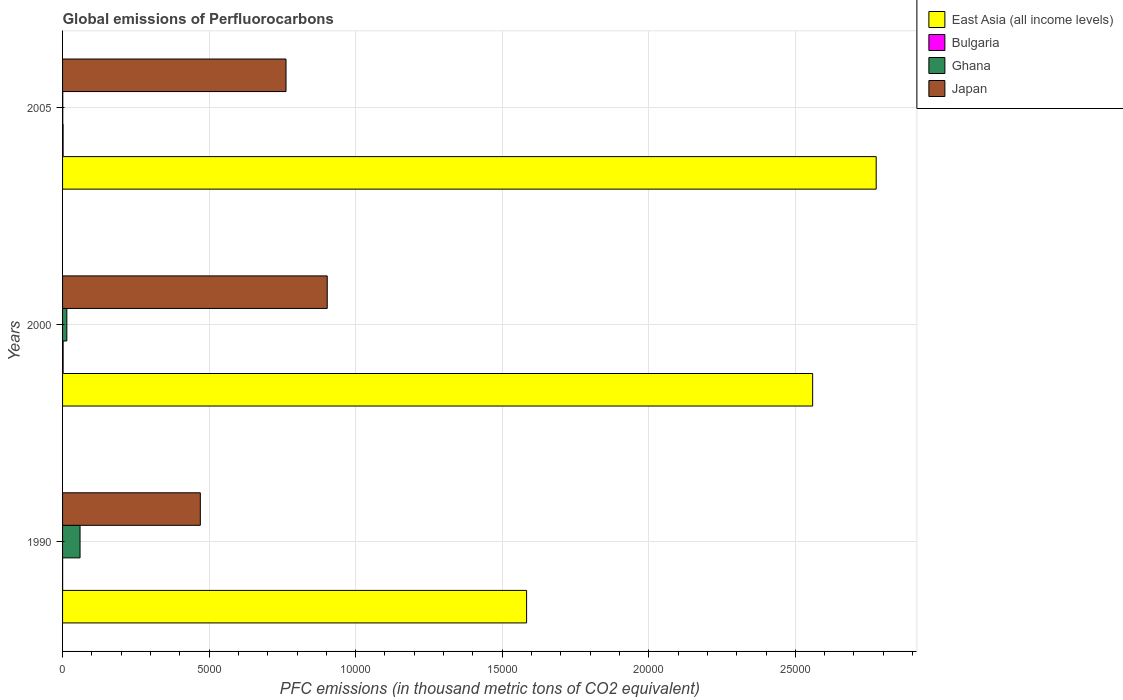How many different coloured bars are there?
Provide a short and direct response. 4. Are the number of bars on each tick of the Y-axis equal?
Make the answer very short. Yes. How many bars are there on the 1st tick from the top?
Offer a very short reply. 4. How many bars are there on the 1st tick from the bottom?
Provide a succinct answer. 4. In how many cases, is the number of bars for a given year not equal to the number of legend labels?
Make the answer very short. 0. What is the global emissions of Perfluorocarbons in Ghana in 2005?
Offer a terse response. 6.9. Across all years, what is the maximum global emissions of Perfluorocarbons in Bulgaria?
Your response must be concise. 19.1. Across all years, what is the minimum global emissions of Perfluorocarbons in Ghana?
Your response must be concise. 6.9. What is the total global emissions of Perfluorocarbons in Ghana in the graph?
Offer a very short reply. 749.2. What is the difference between the global emissions of Perfluorocarbons in Bulgaria in 2000 and that in 2005?
Your answer should be compact. 0.6. What is the difference between the global emissions of Perfluorocarbons in Bulgaria in 2005 and the global emissions of Perfluorocarbons in Japan in 2000?
Give a very brief answer. -9011.3. What is the average global emissions of Perfluorocarbons in East Asia (all income levels) per year?
Your response must be concise. 2.31e+04. In the year 2000, what is the difference between the global emissions of Perfluorocarbons in East Asia (all income levels) and global emissions of Perfluorocarbons in Bulgaria?
Make the answer very short. 2.56e+04. In how many years, is the global emissions of Perfluorocarbons in East Asia (all income levels) greater than 10000 thousand metric tons?
Offer a very short reply. 3. What is the ratio of the global emissions of Perfluorocarbons in Ghana in 2000 to that in 2005?
Ensure brevity in your answer.  21.17. What is the difference between the highest and the second highest global emissions of Perfluorocarbons in Bulgaria?
Keep it short and to the point. 0.6. What is the difference between the highest and the lowest global emissions of Perfluorocarbons in Japan?
Ensure brevity in your answer.  4329.8. Is the sum of the global emissions of Perfluorocarbons in Bulgaria in 2000 and 2005 greater than the maximum global emissions of Perfluorocarbons in Japan across all years?
Offer a very short reply. No. Is it the case that in every year, the sum of the global emissions of Perfluorocarbons in Japan and global emissions of Perfluorocarbons in East Asia (all income levels) is greater than the sum of global emissions of Perfluorocarbons in Ghana and global emissions of Perfluorocarbons in Bulgaria?
Ensure brevity in your answer.  Yes. What does the 4th bar from the top in 1990 represents?
Offer a terse response. East Asia (all income levels). Is it the case that in every year, the sum of the global emissions of Perfluorocarbons in Japan and global emissions of Perfluorocarbons in East Asia (all income levels) is greater than the global emissions of Perfluorocarbons in Bulgaria?
Your response must be concise. Yes. How many bars are there?
Ensure brevity in your answer.  12. Are all the bars in the graph horizontal?
Make the answer very short. Yes. Where does the legend appear in the graph?
Give a very brief answer. Top right. How many legend labels are there?
Ensure brevity in your answer.  4. How are the legend labels stacked?
Make the answer very short. Vertical. What is the title of the graph?
Provide a succinct answer. Global emissions of Perfluorocarbons. Does "Peru" appear as one of the legend labels in the graph?
Your answer should be very brief. No. What is the label or title of the X-axis?
Your answer should be compact. PFC emissions (in thousand metric tons of CO2 equivalent). What is the PFC emissions (in thousand metric tons of CO2 equivalent) of East Asia (all income levels) in 1990?
Make the answer very short. 1.58e+04. What is the PFC emissions (in thousand metric tons of CO2 equivalent) in Ghana in 1990?
Ensure brevity in your answer.  596.2. What is the PFC emissions (in thousand metric tons of CO2 equivalent) of Japan in 1990?
Your response must be concise. 4700. What is the PFC emissions (in thousand metric tons of CO2 equivalent) in East Asia (all income levels) in 2000?
Your answer should be compact. 2.56e+04. What is the PFC emissions (in thousand metric tons of CO2 equivalent) of Bulgaria in 2000?
Keep it short and to the point. 19.1. What is the PFC emissions (in thousand metric tons of CO2 equivalent) in Ghana in 2000?
Provide a short and direct response. 146.1. What is the PFC emissions (in thousand metric tons of CO2 equivalent) in Japan in 2000?
Ensure brevity in your answer.  9029.8. What is the PFC emissions (in thousand metric tons of CO2 equivalent) in East Asia (all income levels) in 2005?
Keep it short and to the point. 2.78e+04. What is the PFC emissions (in thousand metric tons of CO2 equivalent) of Bulgaria in 2005?
Your answer should be very brief. 18.5. What is the PFC emissions (in thousand metric tons of CO2 equivalent) in Japan in 2005?
Your response must be concise. 7623.6. Across all years, what is the maximum PFC emissions (in thousand metric tons of CO2 equivalent) of East Asia (all income levels)?
Ensure brevity in your answer.  2.78e+04. Across all years, what is the maximum PFC emissions (in thousand metric tons of CO2 equivalent) of Ghana?
Provide a succinct answer. 596.2. Across all years, what is the maximum PFC emissions (in thousand metric tons of CO2 equivalent) in Japan?
Provide a succinct answer. 9029.8. Across all years, what is the minimum PFC emissions (in thousand metric tons of CO2 equivalent) of East Asia (all income levels)?
Provide a succinct answer. 1.58e+04. Across all years, what is the minimum PFC emissions (in thousand metric tons of CO2 equivalent) in Japan?
Ensure brevity in your answer.  4700. What is the total PFC emissions (in thousand metric tons of CO2 equivalent) of East Asia (all income levels) in the graph?
Keep it short and to the point. 6.92e+04. What is the total PFC emissions (in thousand metric tons of CO2 equivalent) of Bulgaria in the graph?
Your answer should be very brief. 39.8. What is the total PFC emissions (in thousand metric tons of CO2 equivalent) of Ghana in the graph?
Ensure brevity in your answer.  749.2. What is the total PFC emissions (in thousand metric tons of CO2 equivalent) in Japan in the graph?
Ensure brevity in your answer.  2.14e+04. What is the difference between the PFC emissions (in thousand metric tons of CO2 equivalent) of East Asia (all income levels) in 1990 and that in 2000?
Your answer should be very brief. -9759.3. What is the difference between the PFC emissions (in thousand metric tons of CO2 equivalent) in Bulgaria in 1990 and that in 2000?
Provide a short and direct response. -16.9. What is the difference between the PFC emissions (in thousand metric tons of CO2 equivalent) of Ghana in 1990 and that in 2000?
Make the answer very short. 450.1. What is the difference between the PFC emissions (in thousand metric tons of CO2 equivalent) in Japan in 1990 and that in 2000?
Keep it short and to the point. -4329.8. What is the difference between the PFC emissions (in thousand metric tons of CO2 equivalent) of East Asia (all income levels) in 1990 and that in 2005?
Provide a succinct answer. -1.19e+04. What is the difference between the PFC emissions (in thousand metric tons of CO2 equivalent) in Bulgaria in 1990 and that in 2005?
Offer a very short reply. -16.3. What is the difference between the PFC emissions (in thousand metric tons of CO2 equivalent) in Ghana in 1990 and that in 2005?
Offer a very short reply. 589.3. What is the difference between the PFC emissions (in thousand metric tons of CO2 equivalent) of Japan in 1990 and that in 2005?
Provide a succinct answer. -2923.6. What is the difference between the PFC emissions (in thousand metric tons of CO2 equivalent) in East Asia (all income levels) in 2000 and that in 2005?
Your response must be concise. -2167.69. What is the difference between the PFC emissions (in thousand metric tons of CO2 equivalent) of Bulgaria in 2000 and that in 2005?
Ensure brevity in your answer.  0.6. What is the difference between the PFC emissions (in thousand metric tons of CO2 equivalent) of Ghana in 2000 and that in 2005?
Your answer should be compact. 139.2. What is the difference between the PFC emissions (in thousand metric tons of CO2 equivalent) in Japan in 2000 and that in 2005?
Your answer should be very brief. 1406.2. What is the difference between the PFC emissions (in thousand metric tons of CO2 equivalent) of East Asia (all income levels) in 1990 and the PFC emissions (in thousand metric tons of CO2 equivalent) of Bulgaria in 2000?
Provide a succinct answer. 1.58e+04. What is the difference between the PFC emissions (in thousand metric tons of CO2 equivalent) in East Asia (all income levels) in 1990 and the PFC emissions (in thousand metric tons of CO2 equivalent) in Ghana in 2000?
Ensure brevity in your answer.  1.57e+04. What is the difference between the PFC emissions (in thousand metric tons of CO2 equivalent) in East Asia (all income levels) in 1990 and the PFC emissions (in thousand metric tons of CO2 equivalent) in Japan in 2000?
Provide a succinct answer. 6801.9. What is the difference between the PFC emissions (in thousand metric tons of CO2 equivalent) of Bulgaria in 1990 and the PFC emissions (in thousand metric tons of CO2 equivalent) of Ghana in 2000?
Your answer should be compact. -143.9. What is the difference between the PFC emissions (in thousand metric tons of CO2 equivalent) of Bulgaria in 1990 and the PFC emissions (in thousand metric tons of CO2 equivalent) of Japan in 2000?
Give a very brief answer. -9027.6. What is the difference between the PFC emissions (in thousand metric tons of CO2 equivalent) in Ghana in 1990 and the PFC emissions (in thousand metric tons of CO2 equivalent) in Japan in 2000?
Your response must be concise. -8433.6. What is the difference between the PFC emissions (in thousand metric tons of CO2 equivalent) in East Asia (all income levels) in 1990 and the PFC emissions (in thousand metric tons of CO2 equivalent) in Bulgaria in 2005?
Keep it short and to the point. 1.58e+04. What is the difference between the PFC emissions (in thousand metric tons of CO2 equivalent) in East Asia (all income levels) in 1990 and the PFC emissions (in thousand metric tons of CO2 equivalent) in Ghana in 2005?
Provide a short and direct response. 1.58e+04. What is the difference between the PFC emissions (in thousand metric tons of CO2 equivalent) of East Asia (all income levels) in 1990 and the PFC emissions (in thousand metric tons of CO2 equivalent) of Japan in 2005?
Make the answer very short. 8208.1. What is the difference between the PFC emissions (in thousand metric tons of CO2 equivalent) of Bulgaria in 1990 and the PFC emissions (in thousand metric tons of CO2 equivalent) of Ghana in 2005?
Provide a succinct answer. -4.7. What is the difference between the PFC emissions (in thousand metric tons of CO2 equivalent) of Bulgaria in 1990 and the PFC emissions (in thousand metric tons of CO2 equivalent) of Japan in 2005?
Your answer should be very brief. -7621.4. What is the difference between the PFC emissions (in thousand metric tons of CO2 equivalent) in Ghana in 1990 and the PFC emissions (in thousand metric tons of CO2 equivalent) in Japan in 2005?
Your answer should be very brief. -7027.4. What is the difference between the PFC emissions (in thousand metric tons of CO2 equivalent) in East Asia (all income levels) in 2000 and the PFC emissions (in thousand metric tons of CO2 equivalent) in Bulgaria in 2005?
Your answer should be compact. 2.56e+04. What is the difference between the PFC emissions (in thousand metric tons of CO2 equivalent) of East Asia (all income levels) in 2000 and the PFC emissions (in thousand metric tons of CO2 equivalent) of Ghana in 2005?
Give a very brief answer. 2.56e+04. What is the difference between the PFC emissions (in thousand metric tons of CO2 equivalent) in East Asia (all income levels) in 2000 and the PFC emissions (in thousand metric tons of CO2 equivalent) in Japan in 2005?
Provide a succinct answer. 1.80e+04. What is the difference between the PFC emissions (in thousand metric tons of CO2 equivalent) in Bulgaria in 2000 and the PFC emissions (in thousand metric tons of CO2 equivalent) in Ghana in 2005?
Provide a short and direct response. 12.2. What is the difference between the PFC emissions (in thousand metric tons of CO2 equivalent) of Bulgaria in 2000 and the PFC emissions (in thousand metric tons of CO2 equivalent) of Japan in 2005?
Make the answer very short. -7604.5. What is the difference between the PFC emissions (in thousand metric tons of CO2 equivalent) of Ghana in 2000 and the PFC emissions (in thousand metric tons of CO2 equivalent) of Japan in 2005?
Keep it short and to the point. -7477.5. What is the average PFC emissions (in thousand metric tons of CO2 equivalent) in East Asia (all income levels) per year?
Your answer should be compact. 2.31e+04. What is the average PFC emissions (in thousand metric tons of CO2 equivalent) in Bulgaria per year?
Make the answer very short. 13.27. What is the average PFC emissions (in thousand metric tons of CO2 equivalent) of Ghana per year?
Ensure brevity in your answer.  249.73. What is the average PFC emissions (in thousand metric tons of CO2 equivalent) in Japan per year?
Provide a short and direct response. 7117.8. In the year 1990, what is the difference between the PFC emissions (in thousand metric tons of CO2 equivalent) of East Asia (all income levels) and PFC emissions (in thousand metric tons of CO2 equivalent) of Bulgaria?
Your response must be concise. 1.58e+04. In the year 1990, what is the difference between the PFC emissions (in thousand metric tons of CO2 equivalent) of East Asia (all income levels) and PFC emissions (in thousand metric tons of CO2 equivalent) of Ghana?
Ensure brevity in your answer.  1.52e+04. In the year 1990, what is the difference between the PFC emissions (in thousand metric tons of CO2 equivalent) in East Asia (all income levels) and PFC emissions (in thousand metric tons of CO2 equivalent) in Japan?
Provide a short and direct response. 1.11e+04. In the year 1990, what is the difference between the PFC emissions (in thousand metric tons of CO2 equivalent) in Bulgaria and PFC emissions (in thousand metric tons of CO2 equivalent) in Ghana?
Provide a short and direct response. -594. In the year 1990, what is the difference between the PFC emissions (in thousand metric tons of CO2 equivalent) of Bulgaria and PFC emissions (in thousand metric tons of CO2 equivalent) of Japan?
Give a very brief answer. -4697.8. In the year 1990, what is the difference between the PFC emissions (in thousand metric tons of CO2 equivalent) in Ghana and PFC emissions (in thousand metric tons of CO2 equivalent) in Japan?
Keep it short and to the point. -4103.8. In the year 2000, what is the difference between the PFC emissions (in thousand metric tons of CO2 equivalent) of East Asia (all income levels) and PFC emissions (in thousand metric tons of CO2 equivalent) of Bulgaria?
Ensure brevity in your answer.  2.56e+04. In the year 2000, what is the difference between the PFC emissions (in thousand metric tons of CO2 equivalent) of East Asia (all income levels) and PFC emissions (in thousand metric tons of CO2 equivalent) of Ghana?
Offer a very short reply. 2.54e+04. In the year 2000, what is the difference between the PFC emissions (in thousand metric tons of CO2 equivalent) in East Asia (all income levels) and PFC emissions (in thousand metric tons of CO2 equivalent) in Japan?
Give a very brief answer. 1.66e+04. In the year 2000, what is the difference between the PFC emissions (in thousand metric tons of CO2 equivalent) in Bulgaria and PFC emissions (in thousand metric tons of CO2 equivalent) in Ghana?
Give a very brief answer. -127. In the year 2000, what is the difference between the PFC emissions (in thousand metric tons of CO2 equivalent) in Bulgaria and PFC emissions (in thousand metric tons of CO2 equivalent) in Japan?
Your answer should be compact. -9010.7. In the year 2000, what is the difference between the PFC emissions (in thousand metric tons of CO2 equivalent) in Ghana and PFC emissions (in thousand metric tons of CO2 equivalent) in Japan?
Give a very brief answer. -8883.7. In the year 2005, what is the difference between the PFC emissions (in thousand metric tons of CO2 equivalent) of East Asia (all income levels) and PFC emissions (in thousand metric tons of CO2 equivalent) of Bulgaria?
Make the answer very short. 2.77e+04. In the year 2005, what is the difference between the PFC emissions (in thousand metric tons of CO2 equivalent) of East Asia (all income levels) and PFC emissions (in thousand metric tons of CO2 equivalent) of Ghana?
Your answer should be compact. 2.78e+04. In the year 2005, what is the difference between the PFC emissions (in thousand metric tons of CO2 equivalent) of East Asia (all income levels) and PFC emissions (in thousand metric tons of CO2 equivalent) of Japan?
Offer a very short reply. 2.01e+04. In the year 2005, what is the difference between the PFC emissions (in thousand metric tons of CO2 equivalent) of Bulgaria and PFC emissions (in thousand metric tons of CO2 equivalent) of Ghana?
Keep it short and to the point. 11.6. In the year 2005, what is the difference between the PFC emissions (in thousand metric tons of CO2 equivalent) in Bulgaria and PFC emissions (in thousand metric tons of CO2 equivalent) in Japan?
Ensure brevity in your answer.  -7605.1. In the year 2005, what is the difference between the PFC emissions (in thousand metric tons of CO2 equivalent) in Ghana and PFC emissions (in thousand metric tons of CO2 equivalent) in Japan?
Your response must be concise. -7616.7. What is the ratio of the PFC emissions (in thousand metric tons of CO2 equivalent) of East Asia (all income levels) in 1990 to that in 2000?
Make the answer very short. 0.62. What is the ratio of the PFC emissions (in thousand metric tons of CO2 equivalent) in Bulgaria in 1990 to that in 2000?
Your answer should be compact. 0.12. What is the ratio of the PFC emissions (in thousand metric tons of CO2 equivalent) in Ghana in 1990 to that in 2000?
Make the answer very short. 4.08. What is the ratio of the PFC emissions (in thousand metric tons of CO2 equivalent) of Japan in 1990 to that in 2000?
Your response must be concise. 0.52. What is the ratio of the PFC emissions (in thousand metric tons of CO2 equivalent) in East Asia (all income levels) in 1990 to that in 2005?
Ensure brevity in your answer.  0.57. What is the ratio of the PFC emissions (in thousand metric tons of CO2 equivalent) in Bulgaria in 1990 to that in 2005?
Provide a succinct answer. 0.12. What is the ratio of the PFC emissions (in thousand metric tons of CO2 equivalent) of Ghana in 1990 to that in 2005?
Your answer should be compact. 86.41. What is the ratio of the PFC emissions (in thousand metric tons of CO2 equivalent) in Japan in 1990 to that in 2005?
Give a very brief answer. 0.62. What is the ratio of the PFC emissions (in thousand metric tons of CO2 equivalent) in East Asia (all income levels) in 2000 to that in 2005?
Ensure brevity in your answer.  0.92. What is the ratio of the PFC emissions (in thousand metric tons of CO2 equivalent) in Bulgaria in 2000 to that in 2005?
Provide a short and direct response. 1.03. What is the ratio of the PFC emissions (in thousand metric tons of CO2 equivalent) of Ghana in 2000 to that in 2005?
Provide a succinct answer. 21.17. What is the ratio of the PFC emissions (in thousand metric tons of CO2 equivalent) of Japan in 2000 to that in 2005?
Offer a terse response. 1.18. What is the difference between the highest and the second highest PFC emissions (in thousand metric tons of CO2 equivalent) in East Asia (all income levels)?
Keep it short and to the point. 2167.69. What is the difference between the highest and the second highest PFC emissions (in thousand metric tons of CO2 equivalent) of Bulgaria?
Your answer should be very brief. 0.6. What is the difference between the highest and the second highest PFC emissions (in thousand metric tons of CO2 equivalent) of Ghana?
Your answer should be very brief. 450.1. What is the difference between the highest and the second highest PFC emissions (in thousand metric tons of CO2 equivalent) of Japan?
Offer a terse response. 1406.2. What is the difference between the highest and the lowest PFC emissions (in thousand metric tons of CO2 equivalent) of East Asia (all income levels)?
Provide a short and direct response. 1.19e+04. What is the difference between the highest and the lowest PFC emissions (in thousand metric tons of CO2 equivalent) in Ghana?
Your response must be concise. 589.3. What is the difference between the highest and the lowest PFC emissions (in thousand metric tons of CO2 equivalent) of Japan?
Your answer should be very brief. 4329.8. 